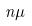Convert formula to latex. <formula><loc_0><loc_0><loc_500><loc_500>n \mu</formula> 